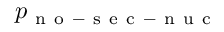<formula> <loc_0><loc_0><loc_500><loc_500>p _ { n o - s e c - n u c }</formula> 